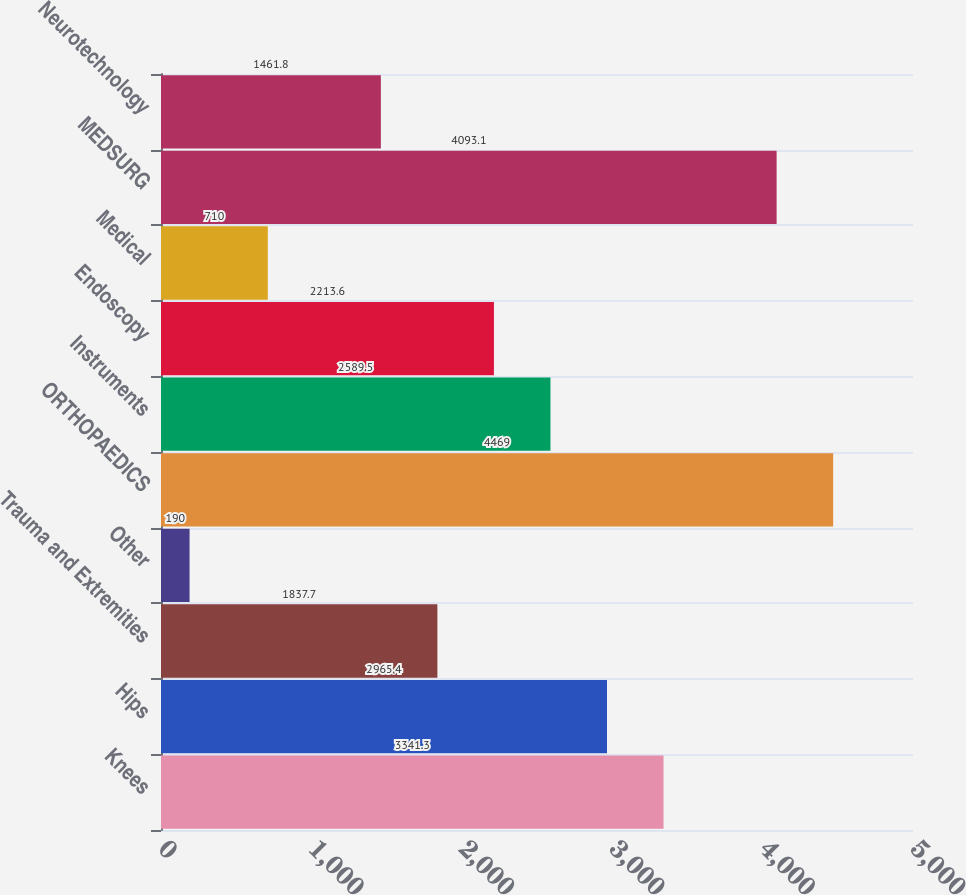Convert chart to OTSL. <chart><loc_0><loc_0><loc_500><loc_500><bar_chart><fcel>Knees<fcel>Hips<fcel>Trauma and Extremities<fcel>Other<fcel>ORTHOPAEDICS<fcel>Instruments<fcel>Endoscopy<fcel>Medical<fcel>MEDSURG<fcel>Neurotechnology<nl><fcel>3341.3<fcel>2965.4<fcel>1837.7<fcel>190<fcel>4469<fcel>2589.5<fcel>2213.6<fcel>710<fcel>4093.1<fcel>1461.8<nl></chart> 